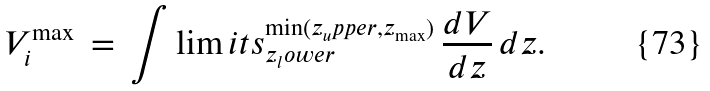Convert formula to latex. <formula><loc_0><loc_0><loc_500><loc_500>V _ { i } ^ { \max } \, = \, \int \lim i t s _ { z _ { l } o w e r } ^ { \min ( z _ { u } p p e r , z _ { \max } ) } \, \frac { d V } { d z } \, d z .</formula> 